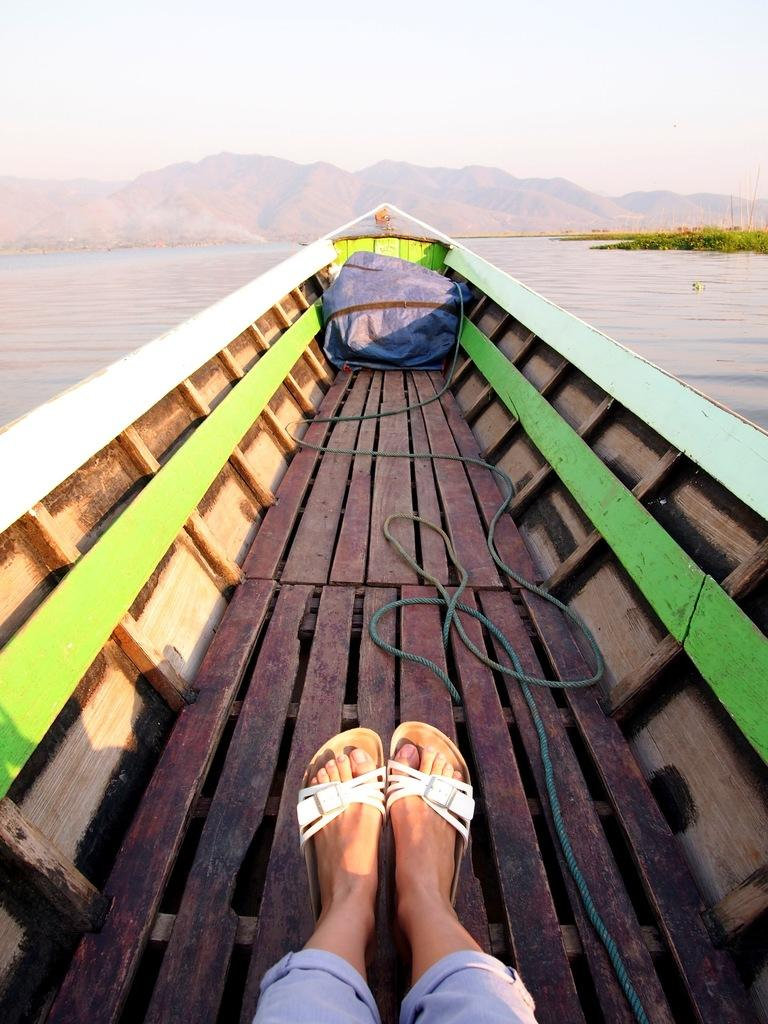What are the people in the image doing? The people in the image are sitting in a boat. What can be seen in the background of the image? There is water, mountains, and a clear sky visible in the background of the image. Can you touch the collar of the dog in the image? There is no dog or collar present in the image. 